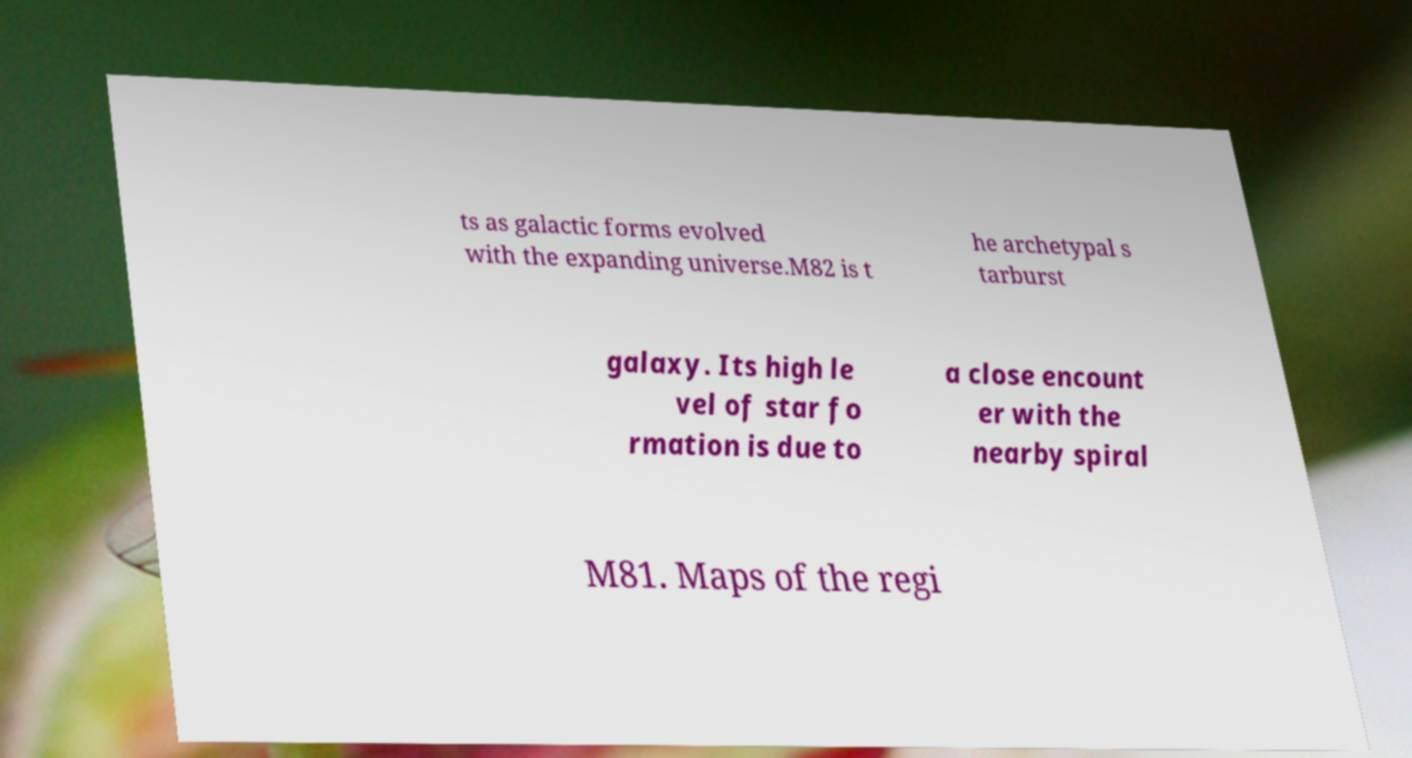Please read and relay the text visible in this image. What does it say? ts as galactic forms evolved with the expanding universe.M82 is t he archetypal s tarburst galaxy. Its high le vel of star fo rmation is due to a close encount er with the nearby spiral M81. Maps of the regi 